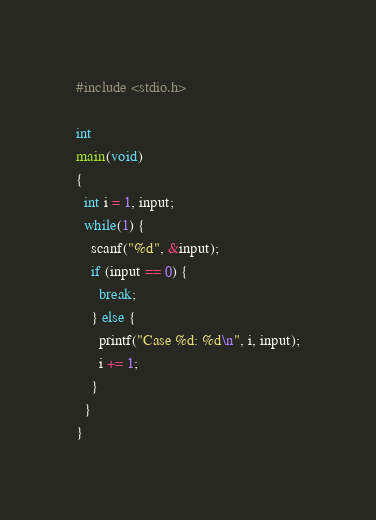Convert code to text. <code><loc_0><loc_0><loc_500><loc_500><_C_>#include <stdio.h>

int
main(void)
{
  int i = 1, input;
  while(1) {
    scanf("%d", &input);
    if (input == 0) {
      break;
    } else {
      printf("Case %d: %d\n", i, input);
      i += 1;
    }
  }
}</code> 